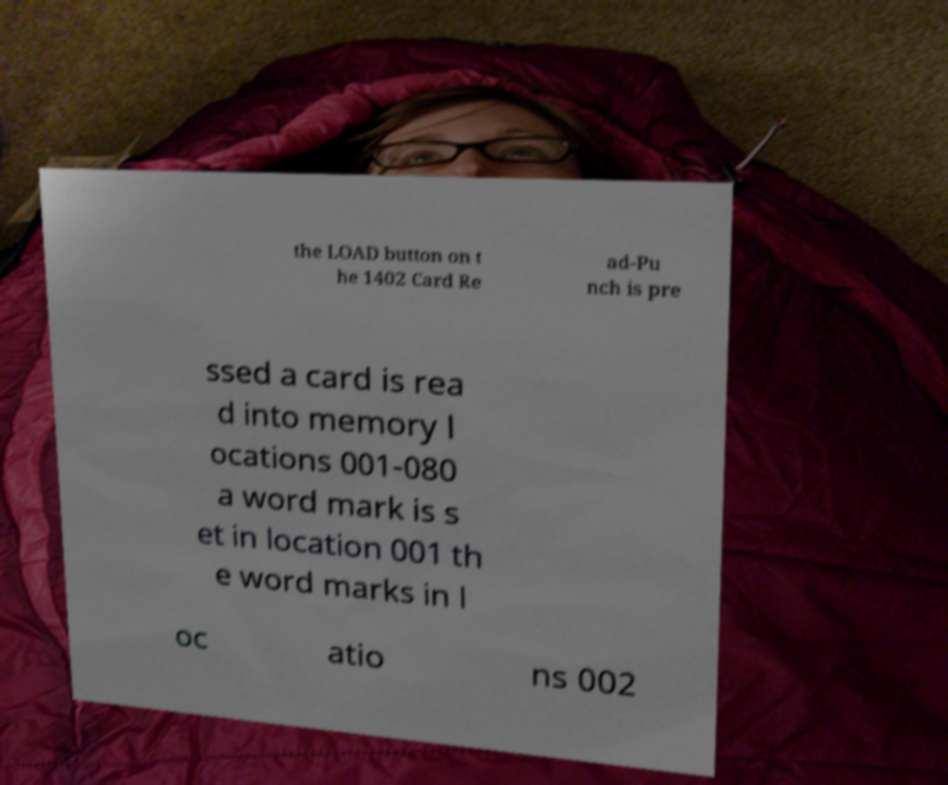Can you accurately transcribe the text from the provided image for me? the LOAD button on t he 1402 Card Re ad-Pu nch is pre ssed a card is rea d into memory l ocations 001-080 a word mark is s et in location 001 th e word marks in l oc atio ns 002 